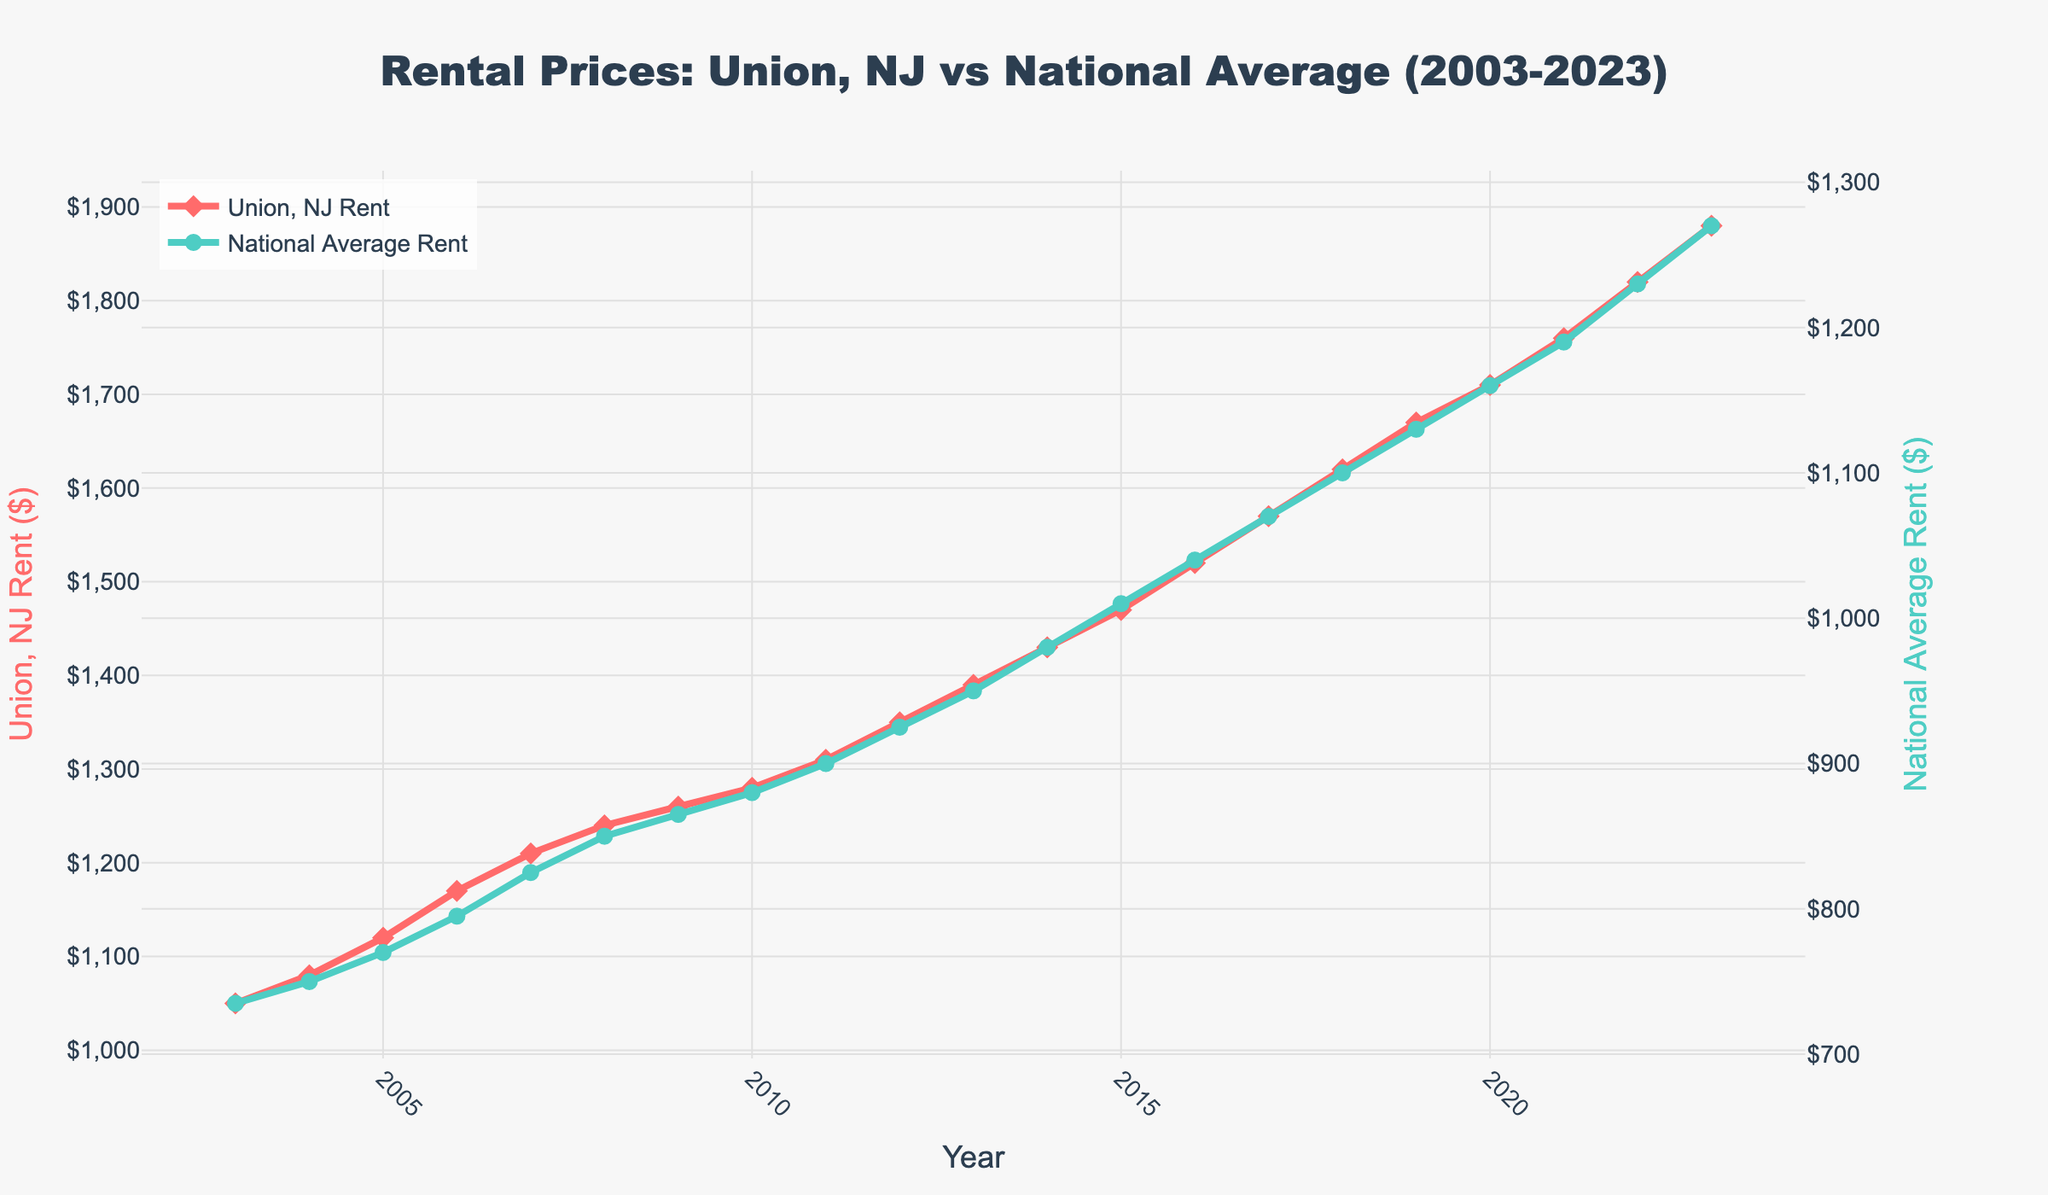What is the rental price in Union, NJ in 2010? Look at the point corresponding to the year 2010 on the red line representing Union, NJ rent and read its value from the y-axis on the left.
Answer: 1280 In which year did the Union, NJ rent first exceed $1700? Identify the first year where the red line crosses above the $1700 mark on the left y-axis.
Answer: 2020 What is the difference between the Union, NJ rent and the national average rent in 2023? Subtract the national average rent value from the Union, NJ rent value in 2023 by referring to the endpoints of both lines.
Answer: 610 How does the trend in Union, NJ rent compare to the national average over the past 20 years? Observe the slopes and direction of both lines over time, noting that both lines show an increasing trend.
Answer: Both increased Which year shows the smallest difference between Union, NJ rent and national average rent? Calculate the yearly differences between the two rents and identify the year with the smallest value using y-axis values for each year.
Answer: 2003 What is the average rent in Union, NJ over the first five years (2003-2007)? Sum the rental prices for Union, NJ for the years 2003 to 2007 and divide by the number of years.
Answer: 1126 By how much did the national average rent increase from 2003 to 2023? Subtract the national average rent in 2003 from the national average rent in 2023 by referencing the values on the right y-axis.
Answer: 535 How much did the Union, NJ rent exceed the national average rent on average each year over the 20-year period? Calculate the difference between Union, NJ rent and national average rent for each year, then average these differences.
Answer: 412.5 At what rate did the Union, NJ rent increase on average per year from 2003 to 2023? Subtract the rent in 2003 from the rent in 2023, then divide by the number of years (20).
Answer: 41.5 per year 